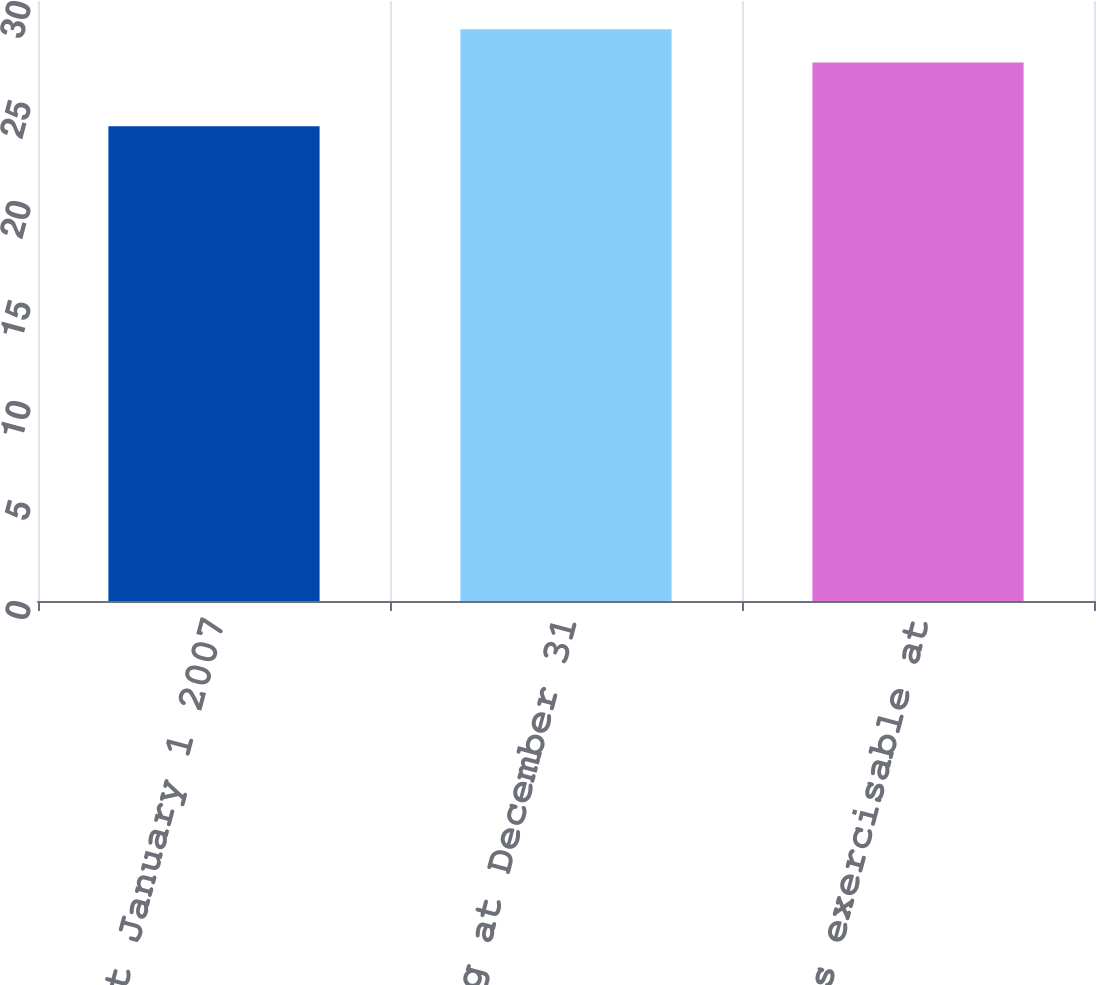<chart> <loc_0><loc_0><loc_500><loc_500><bar_chart><fcel>Outstanding at January 1 2007<fcel>Outstanding at December 31<fcel>Options exercisable at<nl><fcel>23.74<fcel>28.59<fcel>26.92<nl></chart> 